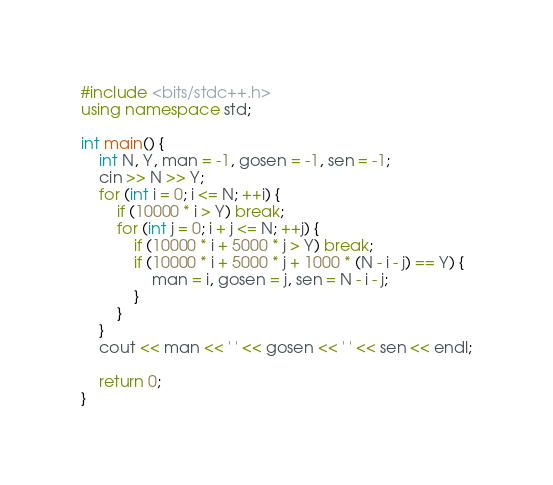Convert code to text. <code><loc_0><loc_0><loc_500><loc_500><_C++_>#include <bits/stdc++.h>
using namespace std;

int main() {
    int N, Y, man = -1, gosen = -1, sen = -1;
    cin >> N >> Y;
    for (int i = 0; i <= N; ++i) {
        if (10000 * i > Y) break;
        for (int j = 0; i + j <= N; ++j) {
            if (10000 * i + 5000 * j > Y) break;
            if (10000 * i + 5000 * j + 1000 * (N - i - j) == Y) {
                man = i, gosen = j, sen = N - i - j;
            }
        }
    }
    cout << man << ' ' << gosen << ' ' << sen << endl;
    
    return 0;
}</code> 